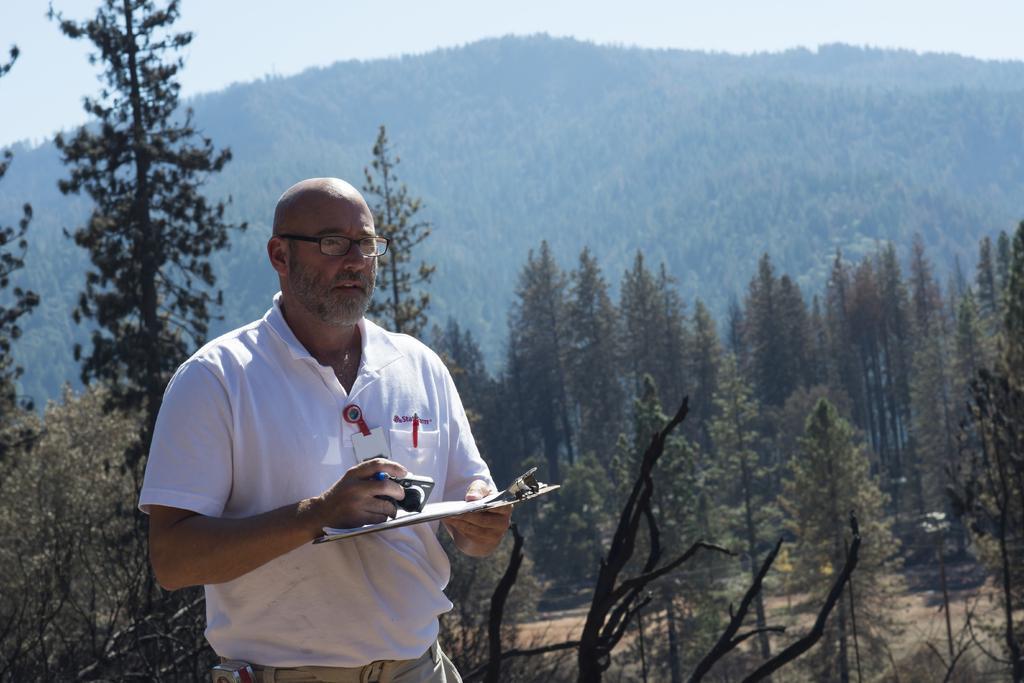Can you describe this image briefly? In this image we can see a person wearing white color T-shirt, holding some pad and camera in his hands standing and in the background of the image there are some trees, mountain and clear sky. 